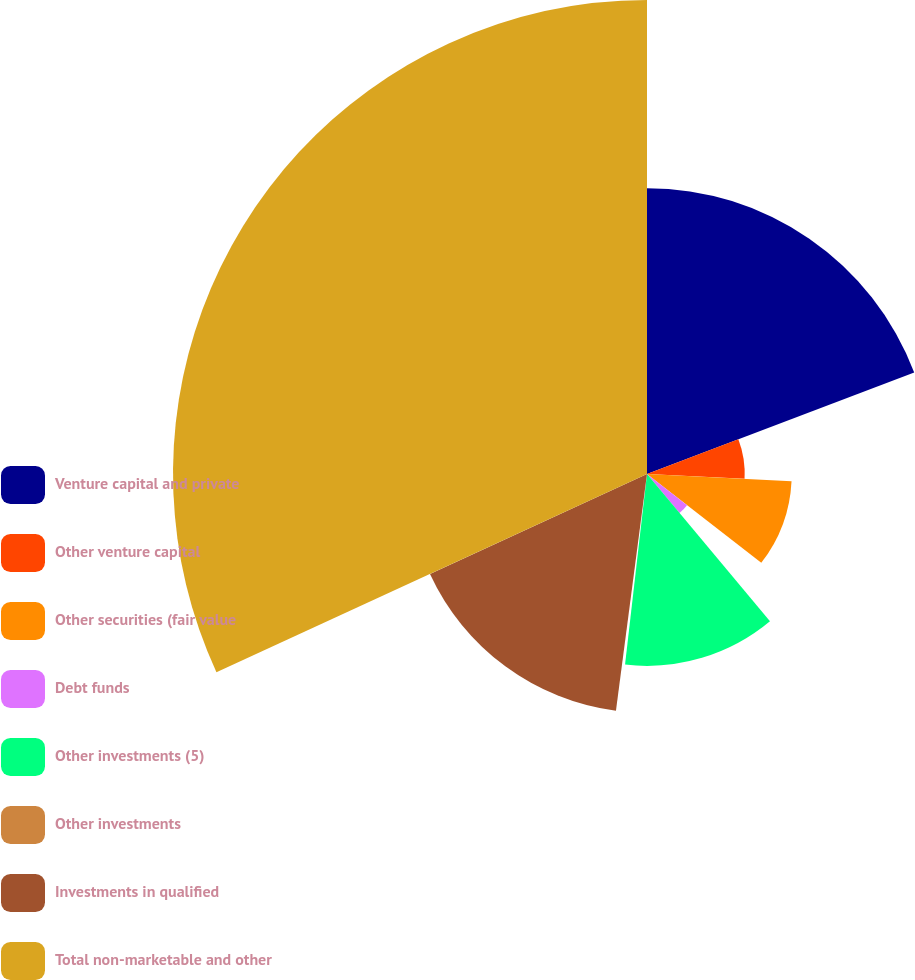<chart> <loc_0><loc_0><loc_500><loc_500><pie_chart><fcel>Venture capital and private<fcel>Other venture capital<fcel>Other securities (fair value<fcel>Debt funds<fcel>Other investments (5)<fcel>Other investments<fcel>Investments in qualified<fcel>Total non-marketable and other<nl><fcel>19.22%<fcel>6.57%<fcel>9.73%<fcel>3.41%<fcel>12.9%<fcel>0.25%<fcel>16.06%<fcel>31.87%<nl></chart> 